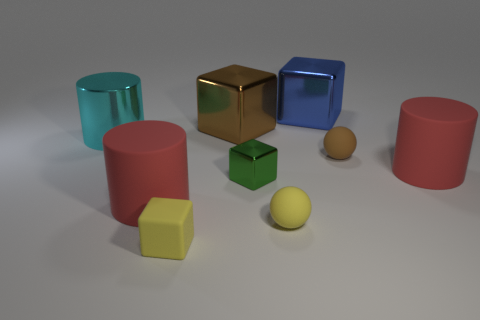Are the tiny cube that is on the right side of the yellow block and the large brown block made of the same material?
Your answer should be very brief. Yes. Are there an equal number of tiny green metal things behind the tiny green object and blue rubber cylinders?
Keep it short and to the point. Yes. The blue block has what size?
Ensure brevity in your answer.  Large. There is a small sphere that is the same color as the small matte block; what is its material?
Ensure brevity in your answer.  Rubber. How many large cylinders have the same color as the small matte block?
Offer a terse response. 0. Do the green object and the matte block have the same size?
Ensure brevity in your answer.  Yes. How big is the rubber cylinder on the right side of the brown thing that is in front of the large brown cube?
Offer a very short reply. Large. There is a tiny rubber cube; does it have the same color as the sphere that is to the left of the large blue thing?
Your answer should be very brief. Yes. Are there any cyan objects of the same size as the shiny cylinder?
Offer a terse response. No. There is a brown object in front of the large cyan object; what size is it?
Give a very brief answer. Small. 